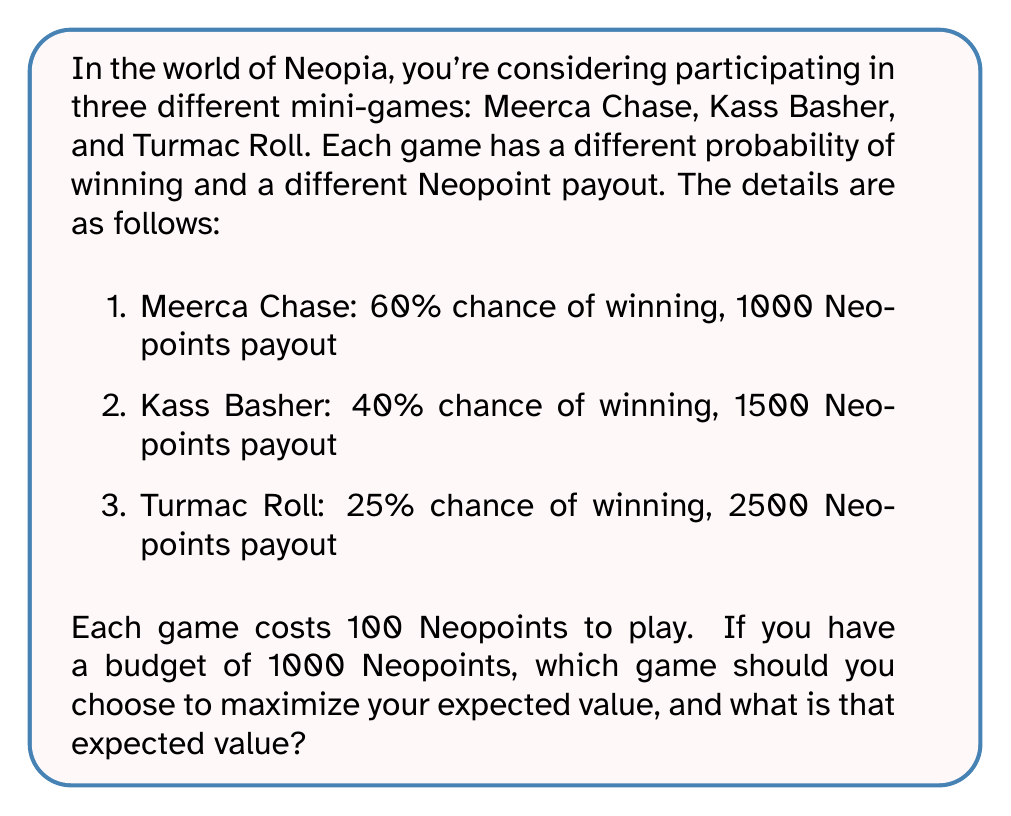Teach me how to tackle this problem. To solve this problem, we need to calculate the expected value for each game and compare them. The expected value is calculated by multiplying the probability of winning by the payout, subtracting the cost to play, and then multiplying by the number of times we can play with our budget.

Let's calculate the expected value for each game:

1. Meerca Chase:
   Expected value per game = (Probability × Payout) - Cost
   $EV_{MC} = (0.60 \times 1000) - 100 = 500$
   Number of games we can play = $1000 \div 100 = 10$
   Total expected value = $500 \times 10 = 5000$ Neopoints

2. Kass Basher:
   $EV_{KB} = (0.40 \times 1500) - 100 = 500$
   Number of games we can play = $1000 \div 100 = 10$
   Total expected value = $500 \times 10 = 5000$ Neopoints

3. Turmac Roll:
   $EV_{TR} = (0.25 \times 2500) - 100 = 525$
   Number of games we can play = $1000 \div 100 = 10$
   Total expected value = $525 \times 10 = 5250$ Neopoints

Comparing the total expected values:
Meerca Chase: 5000 Neopoints
Kass Basher: 5000 Neopoints
Turmac Roll: 5250 Neopoints

Turmac Roll has the highest expected value, so it's the best choice to maximize your expected return.
Answer: You should choose Turmac Roll to maximize your expected value. The expected value is 5250 Neopoints. 